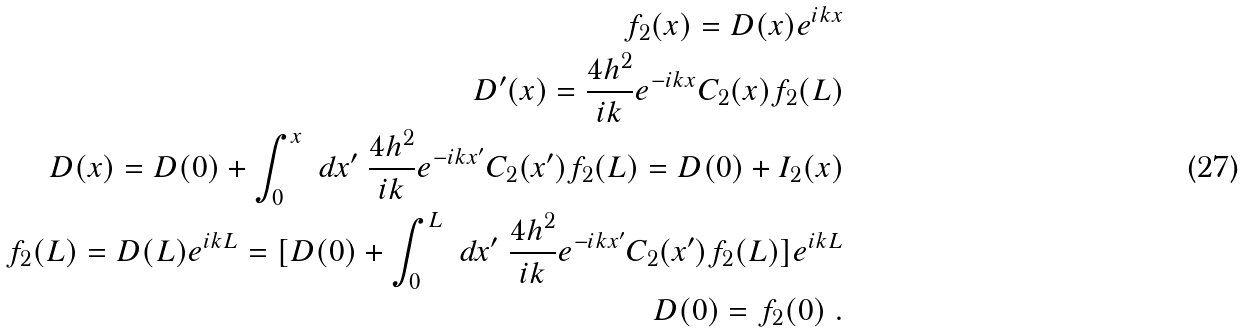<formula> <loc_0><loc_0><loc_500><loc_500>f _ { 2 } ( x ) = D ( x ) e ^ { i k x } \\ D ^ { \prime } ( x ) = \frac { 4 h ^ { 2 } } { i k } e ^ { - i k x } C _ { 2 } ( x ) f _ { 2 } ( L ) \\ D ( x ) = D ( 0 ) + \int _ { 0 } ^ { x } \ d x ^ { \prime } \ \frac { 4 h ^ { 2 } } { i k } e ^ { - i k x ^ { \prime } } C _ { 2 } ( x ^ { \prime } ) f _ { 2 } ( L ) = D ( 0 ) + I _ { 2 } ( x ) \\ f _ { 2 } ( L ) = D ( L ) e ^ { i k L } = [ D ( 0 ) + \int _ { 0 } ^ { L } \ d x ^ { \prime } \ \frac { 4 h ^ { 2 } } { i k } e ^ { - i k x ^ { \prime } } C _ { 2 } ( x ^ { \prime } ) f _ { 2 } ( L ) ] e ^ { i k L } \\ D ( 0 ) = f _ { 2 } ( 0 ) \ .</formula> 